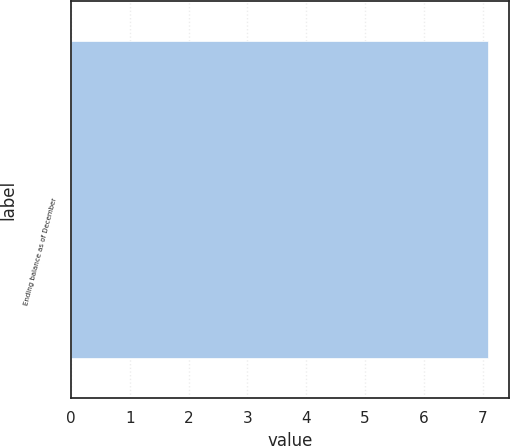Convert chart to OTSL. <chart><loc_0><loc_0><loc_500><loc_500><bar_chart><fcel>Ending balance as of December<nl><fcel>7.1<nl></chart> 